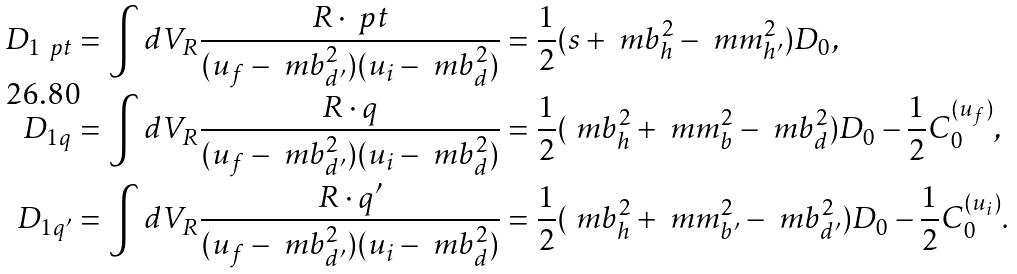Convert formula to latex. <formula><loc_0><loc_0><loc_500><loc_500>D _ { 1 \ p t } & = \int d V _ { R } \frac { R \cdot \ p t } { ( u _ { f } - \ m b _ { d ^ { \prime } } ^ { 2 } ) ( u _ { i } - \ m b _ { d } ^ { 2 } ) } = \frac { 1 } { 2 } ( s + \ m b _ { h } ^ { 2 } - \ m m _ { h ^ { \prime } } ^ { 2 } ) D _ { 0 } , \\ D _ { 1 q } & = \int d V _ { R } \frac { R \cdot q } { ( u _ { f } - \ m b _ { d ^ { \prime } } ^ { 2 } ) ( u _ { i } - \ m b _ { d } ^ { 2 } ) } = \frac { 1 } { 2 } ( \ m b _ { h } ^ { 2 } + \ m m _ { b } ^ { 2 } - \ m b _ { d } ^ { 2 } ) D _ { 0 } - \frac { 1 } { 2 } C _ { 0 } ^ { ( u _ { f } ) } , \\ D _ { 1 q ^ { \prime } } & = \int d V _ { R } \frac { R \cdot q ^ { \prime } } { ( u _ { f } - \ m b _ { d ^ { \prime } } ^ { 2 } ) ( u _ { i } - \ m b _ { d } ^ { 2 } ) } = \frac { 1 } { 2 } ( \ m b _ { h } ^ { 2 } + \ m m _ { b ^ { \prime } } ^ { 2 } - \ m b _ { d ^ { \prime } } ^ { 2 } ) D _ { 0 } - \frac { 1 } { 2 } C _ { 0 } ^ { ( u _ { i } ) } .</formula> 